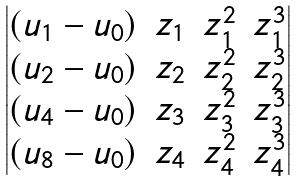Convert formula to latex. <formula><loc_0><loc_0><loc_500><loc_500>\begin{vmatrix} ( u _ { 1 } - u _ { 0 } ) & z _ { 1 } & z _ { 1 } ^ { 2 } & z _ { 1 } ^ { 3 } \\ ( u _ { 2 } - u _ { 0 } ) & z _ { 2 } & z _ { 2 } ^ { 2 } & z _ { 2 } ^ { 3 } \\ ( u _ { 4 } - u _ { 0 } ) & z _ { 3 } & z _ { 3 } ^ { 2 } & z _ { 3 } ^ { 3 } \\ ( u _ { 8 } - u _ { 0 } ) & z _ { 4 } & z _ { 4 } ^ { 2 } & z _ { 4 } ^ { 3 } \end{vmatrix}</formula> 